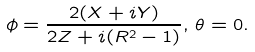Convert formula to latex. <formula><loc_0><loc_0><loc_500><loc_500>\phi = \frac { 2 ( X + i Y ) } { 2 Z + i ( R ^ { 2 } - 1 ) } , \, \theta = 0 .</formula> 